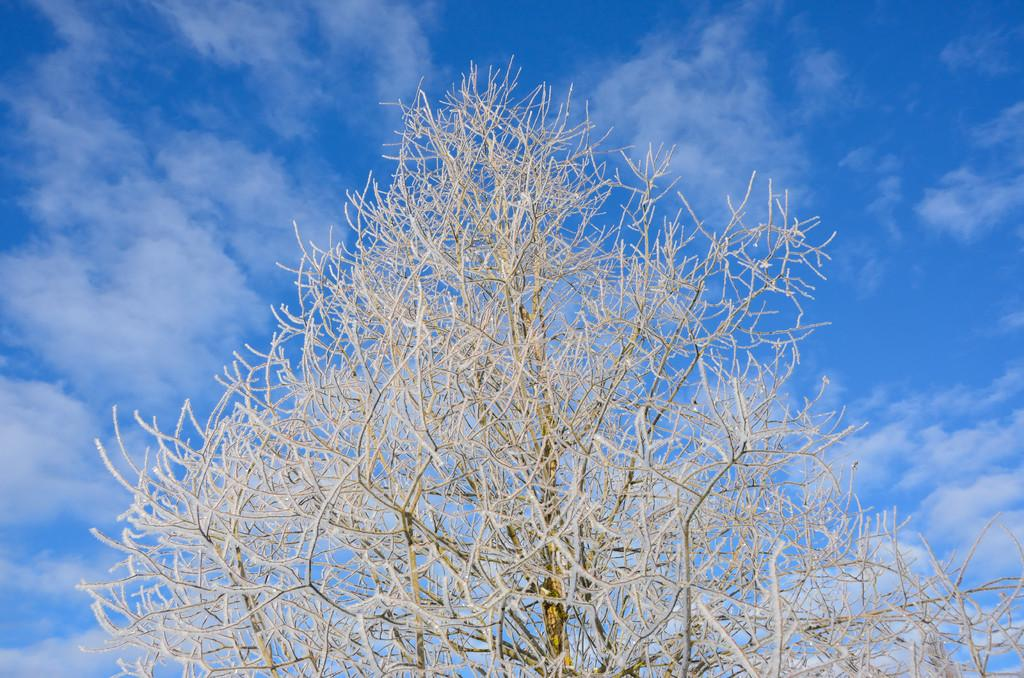What type of tree can be seen in the image? There is a dried tree in the image. What can be seen in the background of the image? The sky is visible in the background of the image. What is present in the sky? Clouds are present in the sky. Can you see a quill being used to write on the dried tree in the image? There is no quill or writing activity present in the image. Is there a boat sailing near the dried tree in the image? There is no boat visible in the image. 